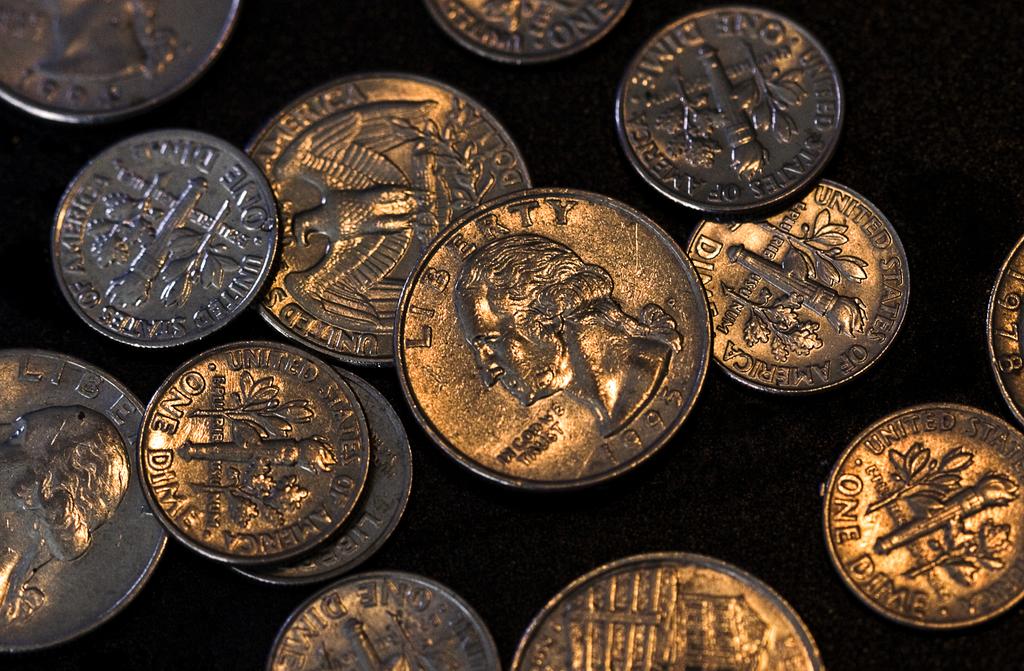What year is the coin in the middle minted?
Your answer should be very brief. 1995. What type of coin is this?
Keep it short and to the point. Quarter. 